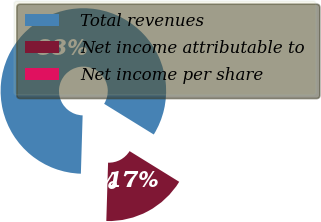<chart> <loc_0><loc_0><loc_500><loc_500><pie_chart><fcel>Total revenues<fcel>Net income attributable to<fcel>Net income per share<nl><fcel>83.33%<fcel>16.67%<fcel>0.0%<nl></chart> 